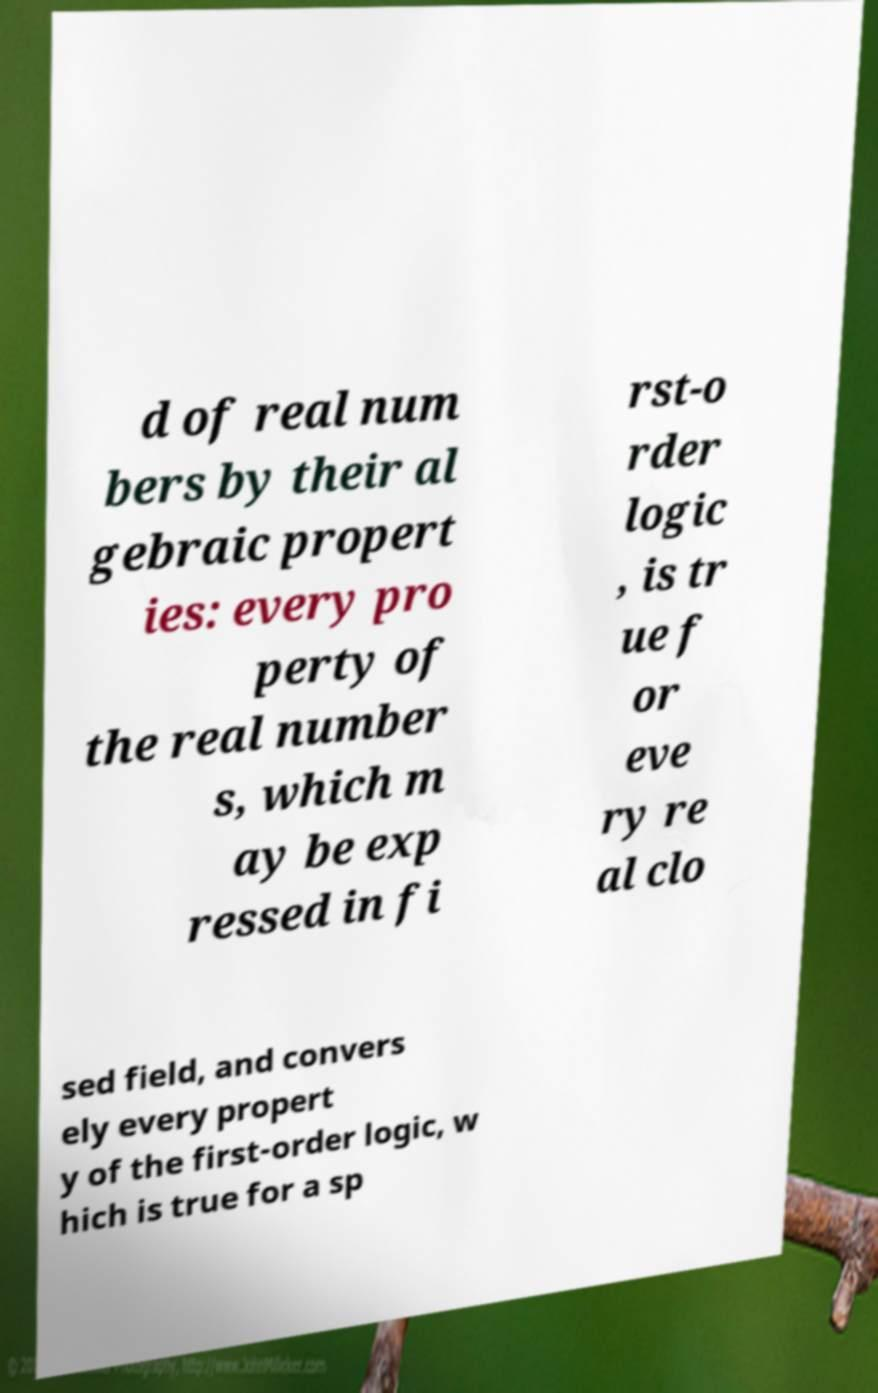Could you assist in decoding the text presented in this image and type it out clearly? d of real num bers by their al gebraic propert ies: every pro perty of the real number s, which m ay be exp ressed in fi rst-o rder logic , is tr ue f or eve ry re al clo sed field, and convers ely every propert y of the first-order logic, w hich is true for a sp 